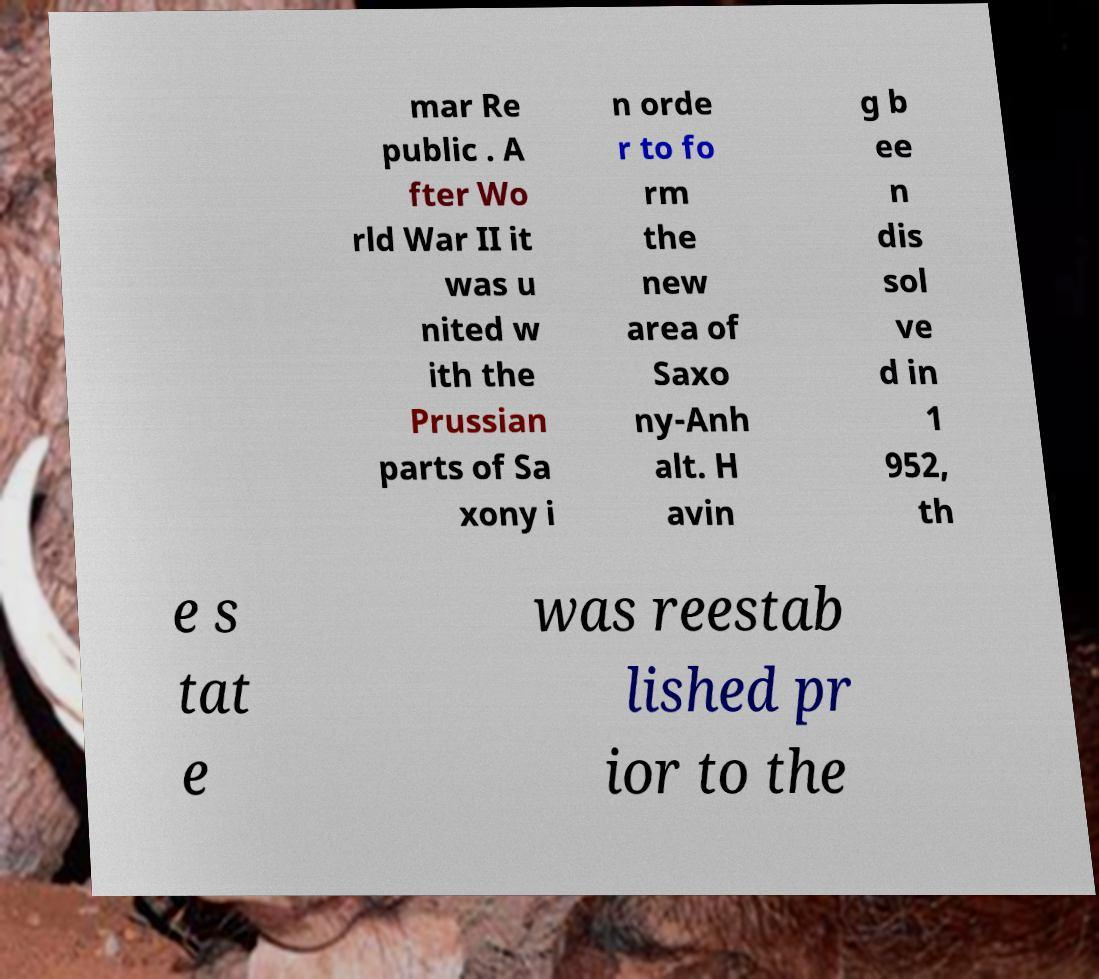For documentation purposes, I need the text within this image transcribed. Could you provide that? mar Re public . A fter Wo rld War II it was u nited w ith the Prussian parts of Sa xony i n orde r to fo rm the new area of Saxo ny-Anh alt. H avin g b ee n dis sol ve d in 1 952, th e s tat e was reestab lished pr ior to the 